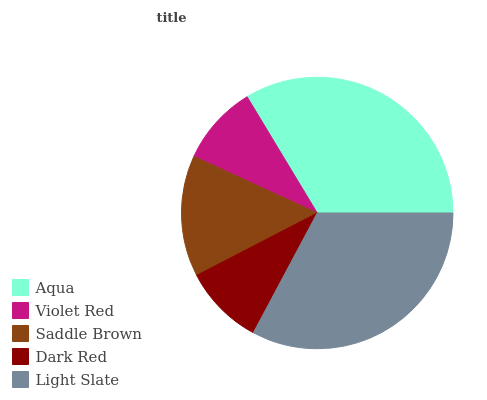Is Violet Red the minimum?
Answer yes or no. Yes. Is Aqua the maximum?
Answer yes or no. Yes. Is Saddle Brown the minimum?
Answer yes or no. No. Is Saddle Brown the maximum?
Answer yes or no. No. Is Saddle Brown greater than Violet Red?
Answer yes or no. Yes. Is Violet Red less than Saddle Brown?
Answer yes or no. Yes. Is Violet Red greater than Saddle Brown?
Answer yes or no. No. Is Saddle Brown less than Violet Red?
Answer yes or no. No. Is Saddle Brown the high median?
Answer yes or no. Yes. Is Saddle Brown the low median?
Answer yes or no. Yes. Is Violet Red the high median?
Answer yes or no. No. Is Light Slate the low median?
Answer yes or no. No. 